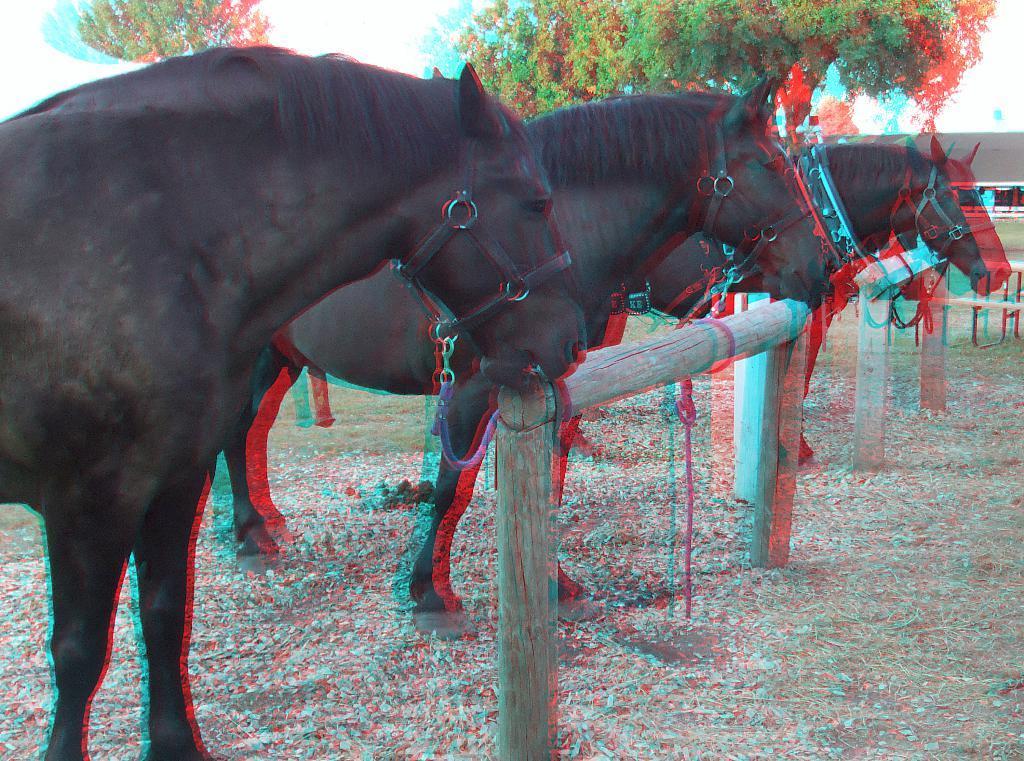Please provide a concise description of this image. In this image we can see three horses tied to the wooden pole, there are some trees, poles and a house, also we can see the sky. 